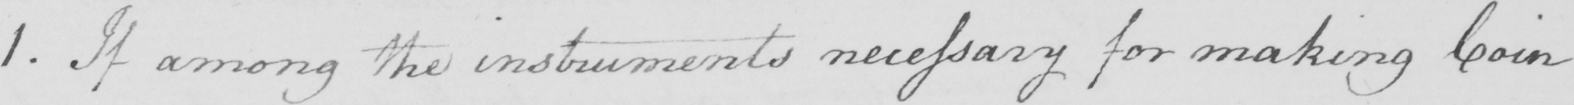Can you read and transcribe this handwriting? 1 . If among the instruments necessary for making Coin 